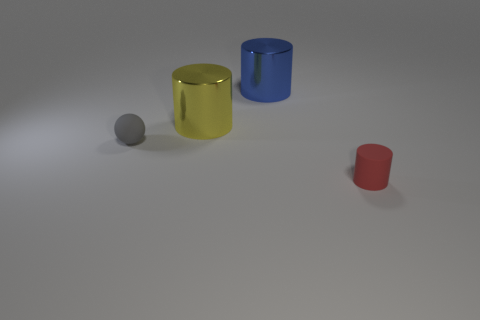Which object appears closest to the perspective of the camera? From the perspective of the camera, the small red cylinder appears to be the closest object. It's positioned in the foreground, while the other objects are arranged further back on the surface. 